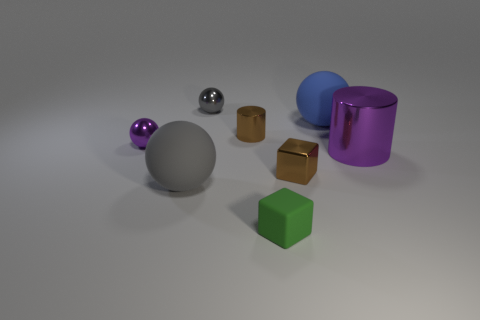The cylinder that is the same color as the tiny metallic block is what size?
Provide a short and direct response. Small. The small brown thing that is in front of the purple sphere in front of the gray metal sphere is what shape?
Provide a short and direct response. Cube. The purple shiny object that is the same size as the blue rubber sphere is what shape?
Provide a succinct answer. Cylinder. Is there a small matte object that has the same shape as the big metallic object?
Your response must be concise. No. What is the green block made of?
Your response must be concise. Rubber. There is a large blue rubber sphere; are there any large purple cylinders behind it?
Your response must be concise. No. How many small balls are in front of the sphere in front of the metallic cube?
Provide a succinct answer. 0. There is a cylinder that is the same size as the gray metallic thing; what is its material?
Your answer should be very brief. Metal. How many other things are made of the same material as the big purple thing?
Your answer should be very brief. 4. There is a blue rubber sphere; how many large blue spheres are in front of it?
Your response must be concise. 0. 